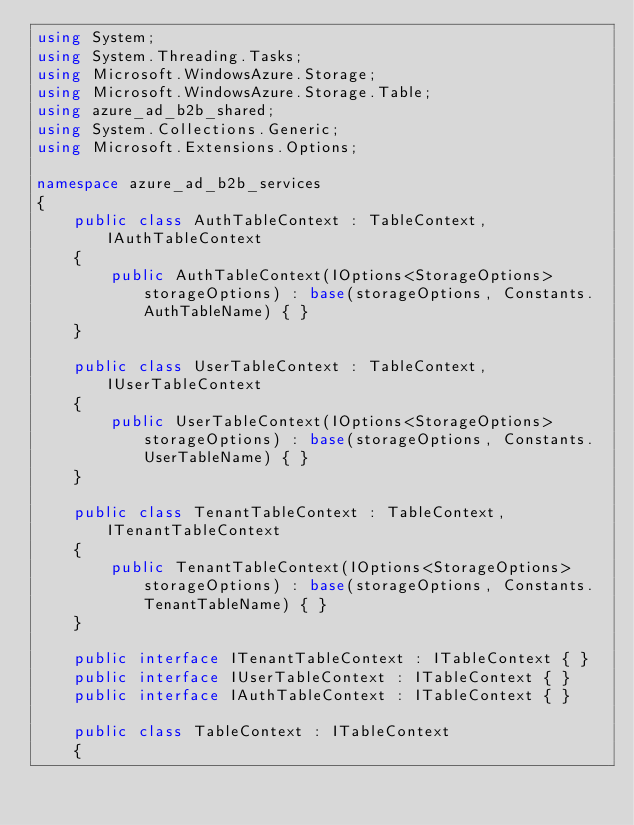<code> <loc_0><loc_0><loc_500><loc_500><_C#_>using System;
using System.Threading.Tasks;
using Microsoft.WindowsAzure.Storage;
using Microsoft.WindowsAzure.Storage.Table;
using azure_ad_b2b_shared;
using System.Collections.Generic;
using Microsoft.Extensions.Options;

namespace azure_ad_b2b_services
{
    public class AuthTableContext : TableContext, IAuthTableContext
    {
        public AuthTableContext(IOptions<StorageOptions> storageOptions) : base(storageOptions, Constants.AuthTableName) { }
    }

    public class UserTableContext : TableContext, IUserTableContext
    {
        public UserTableContext(IOptions<StorageOptions> storageOptions) : base(storageOptions, Constants.UserTableName) { }
    }

    public class TenantTableContext : TableContext, ITenantTableContext
    {
        public TenantTableContext(IOptions<StorageOptions> storageOptions) : base(storageOptions, Constants.TenantTableName) { }
    }

    public interface ITenantTableContext : ITableContext { }
    public interface IUserTableContext : ITableContext { }
    public interface IAuthTableContext : ITableContext { }

    public class TableContext : ITableContext
    {</code> 